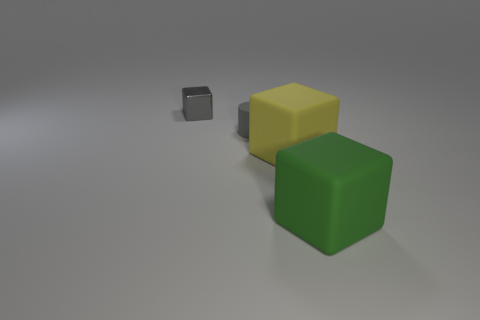Do the shiny object and the tiny cylinder have the same color?
Provide a short and direct response. Yes. What is the color of the thing that is both right of the shiny thing and left of the big yellow rubber object?
Give a very brief answer. Gray. What number of objects are either gray things that are to the left of the small rubber cylinder or rubber cylinders?
Your response must be concise. 2. What is the color of the other large thing that is the same shape as the yellow thing?
Provide a short and direct response. Green. Is the shape of the green object the same as the gray object that is to the right of the tiny metal thing?
Provide a succinct answer. No. What number of things are rubber blocks left of the green object or gray objects that are to the left of the green block?
Ensure brevity in your answer.  3. Are there fewer gray shiny cubes to the left of the small cube than small gray matte cylinders?
Offer a very short reply. Yes. Is the gray block made of the same material as the big object on the left side of the big green rubber cube?
Provide a short and direct response. No. What is the gray cube made of?
Your answer should be very brief. Metal. What material is the gray thing that is behind the gray object in front of the small thing that is left of the tiny matte thing?
Provide a succinct answer. Metal. 